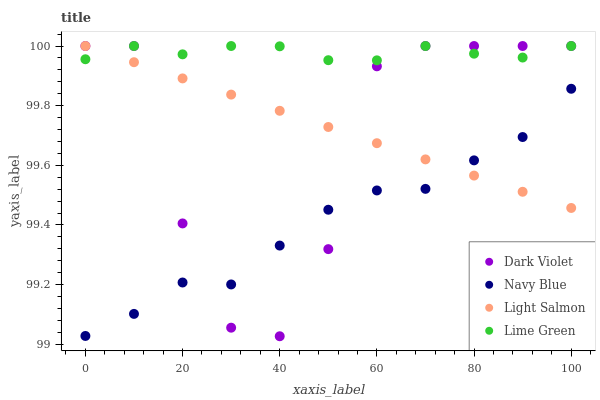Does Navy Blue have the minimum area under the curve?
Answer yes or no. Yes. Does Lime Green have the maximum area under the curve?
Answer yes or no. Yes. Does Light Salmon have the minimum area under the curve?
Answer yes or no. No. Does Light Salmon have the maximum area under the curve?
Answer yes or no. No. Is Light Salmon the smoothest?
Answer yes or no. Yes. Is Dark Violet the roughest?
Answer yes or no. Yes. Is Lime Green the smoothest?
Answer yes or no. No. Is Lime Green the roughest?
Answer yes or no. No. Does Dark Violet have the lowest value?
Answer yes or no. Yes. Does Light Salmon have the lowest value?
Answer yes or no. No. Does Dark Violet have the highest value?
Answer yes or no. Yes. Is Navy Blue less than Lime Green?
Answer yes or no. Yes. Is Lime Green greater than Navy Blue?
Answer yes or no. Yes. Does Navy Blue intersect Light Salmon?
Answer yes or no. Yes. Is Navy Blue less than Light Salmon?
Answer yes or no. No. Is Navy Blue greater than Light Salmon?
Answer yes or no. No. Does Navy Blue intersect Lime Green?
Answer yes or no. No. 